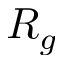<formula> <loc_0><loc_0><loc_500><loc_500>R _ { g }</formula> 